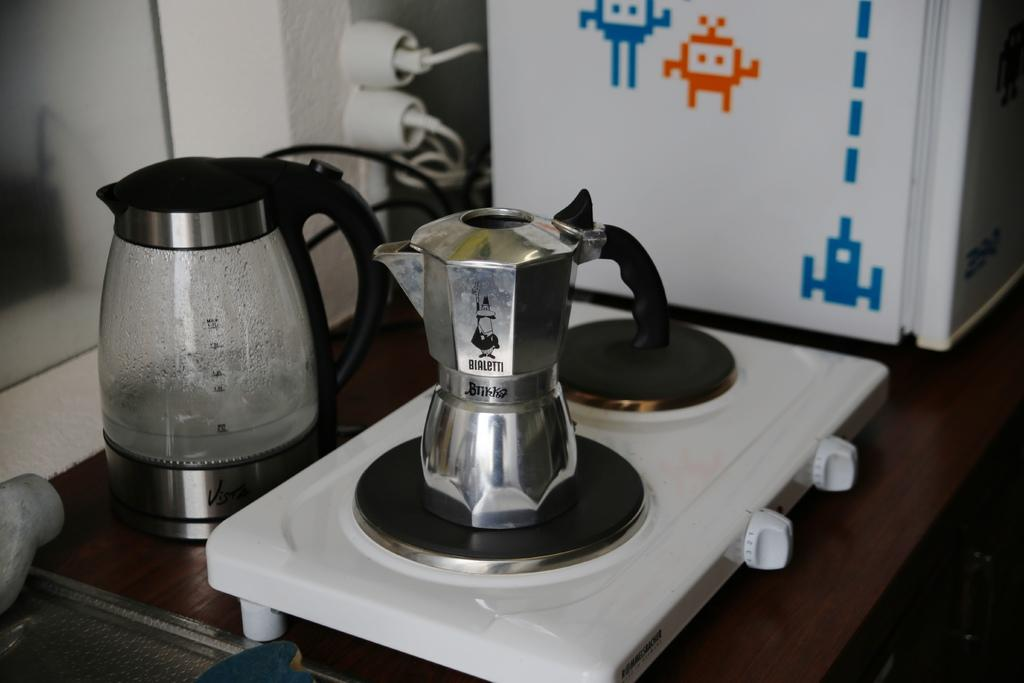<image>
Offer a succinct explanation of the picture presented. a silver cooking device by btikka on the stove 